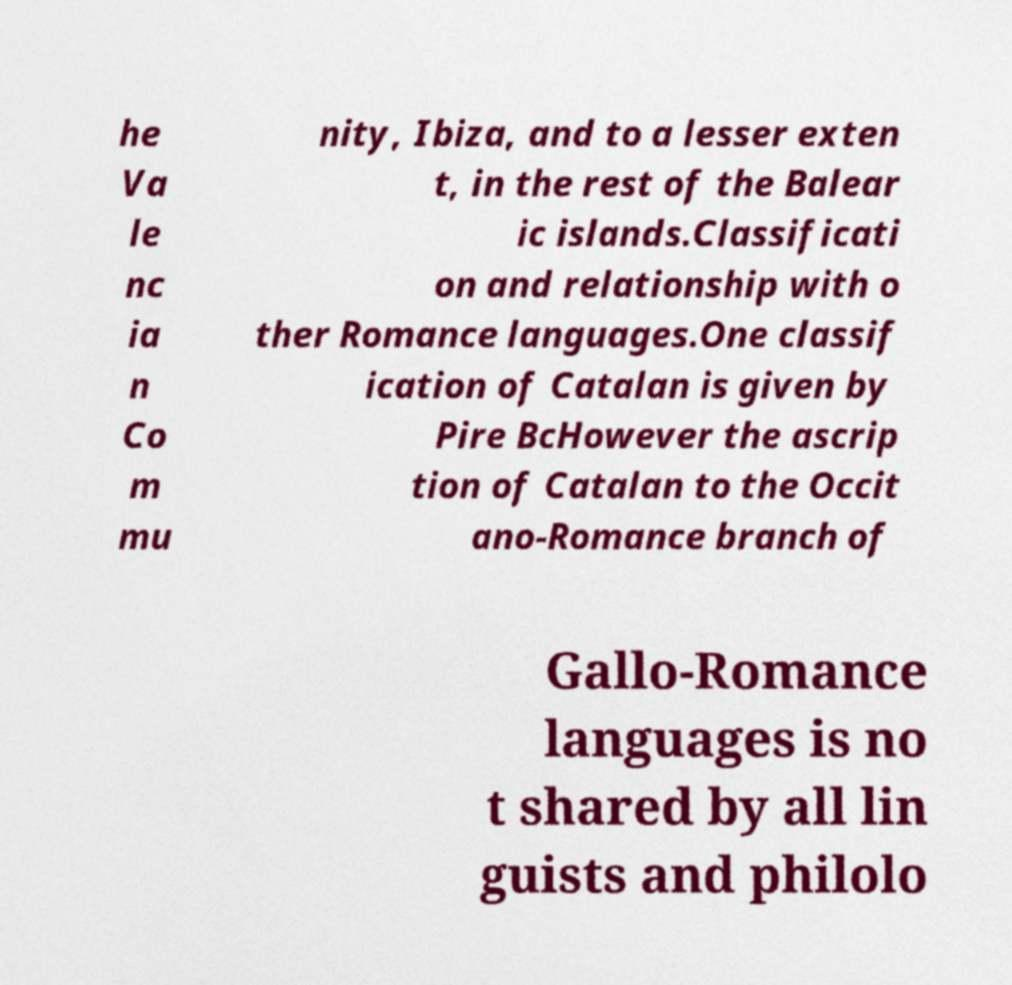Could you extract and type out the text from this image? he Va le nc ia n Co m mu nity, Ibiza, and to a lesser exten t, in the rest of the Balear ic islands.Classificati on and relationship with o ther Romance languages.One classif ication of Catalan is given by Pire BcHowever the ascrip tion of Catalan to the Occit ano-Romance branch of Gallo-Romance languages is no t shared by all lin guists and philolo 